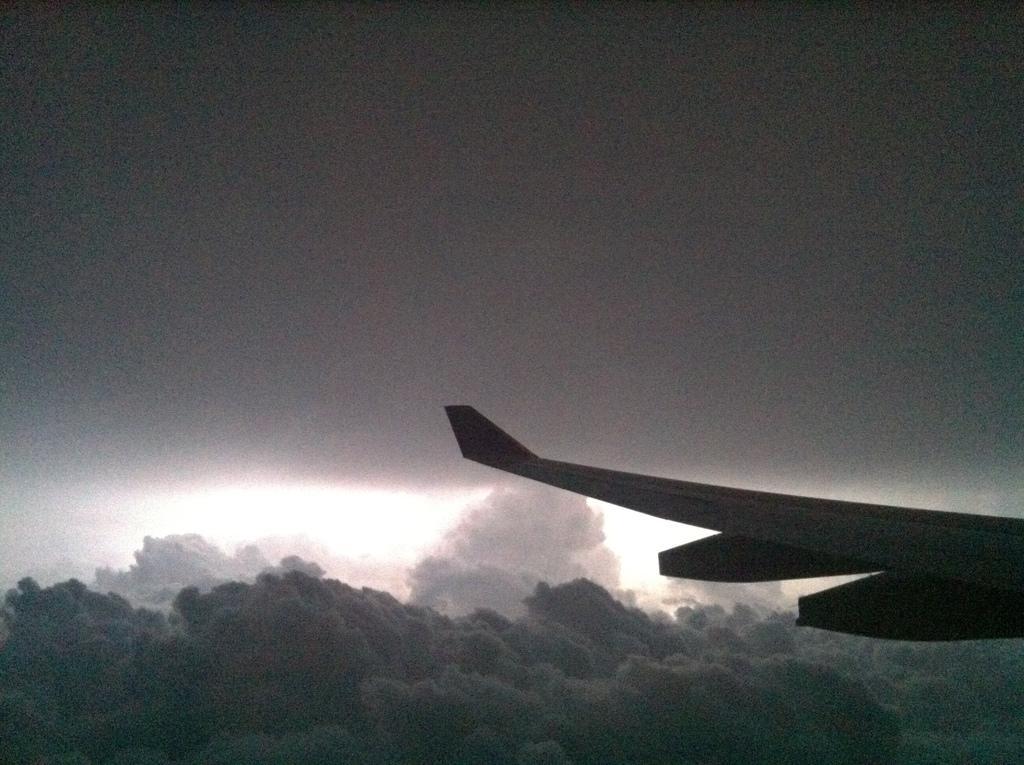Describe this image in one or two sentences. This image consists of a wing of an airplane. In the background, we can see the clouds in the sky. 